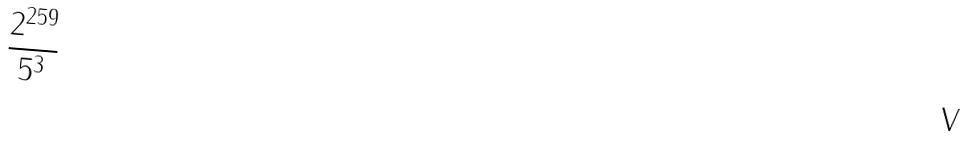<formula> <loc_0><loc_0><loc_500><loc_500>\frac { 2 ^ { 2 5 9 } } { 5 ^ { 3 } }</formula> 